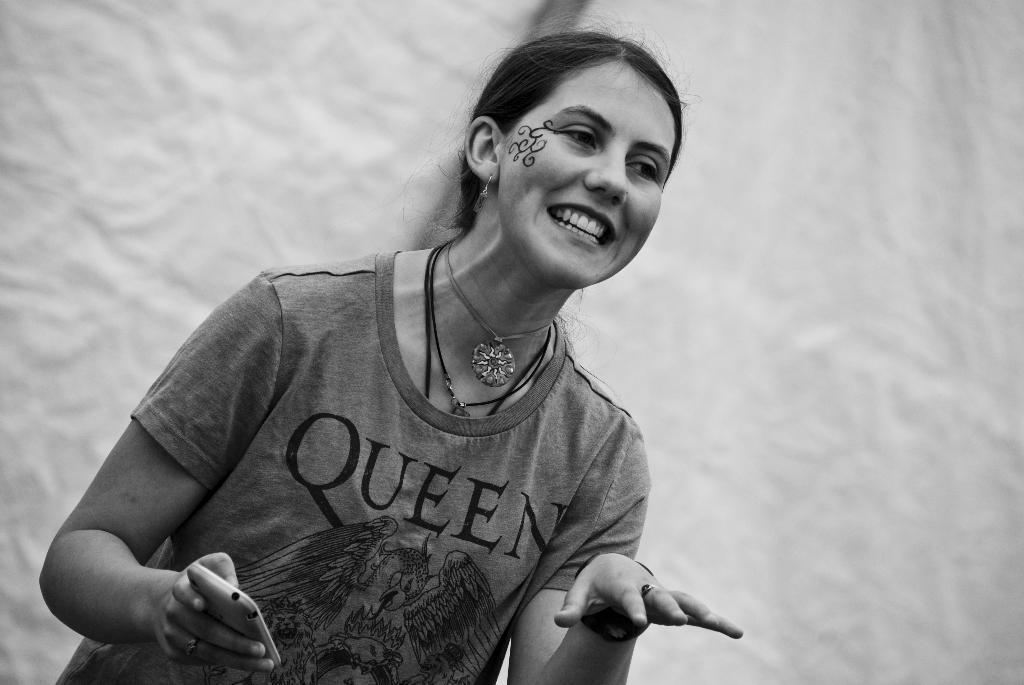How would you summarize this image in a sentence or two? In this picture we can see a woman and she is holding a mobile and in the background we can see the wall. 